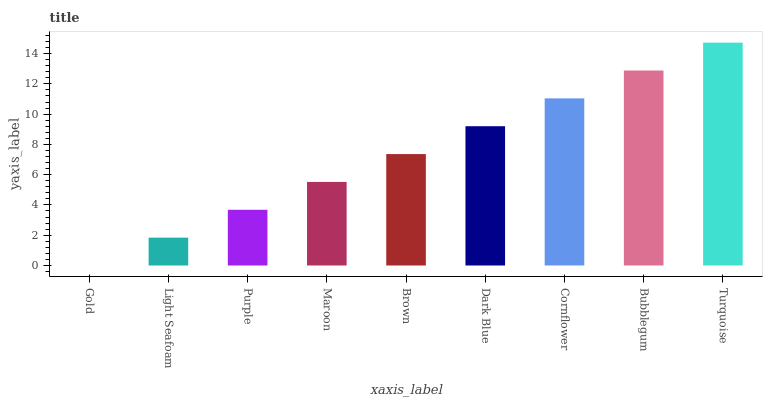Is Gold the minimum?
Answer yes or no. Yes. Is Turquoise the maximum?
Answer yes or no. Yes. Is Light Seafoam the minimum?
Answer yes or no. No. Is Light Seafoam the maximum?
Answer yes or no. No. Is Light Seafoam greater than Gold?
Answer yes or no. Yes. Is Gold less than Light Seafoam?
Answer yes or no. Yes. Is Gold greater than Light Seafoam?
Answer yes or no. No. Is Light Seafoam less than Gold?
Answer yes or no. No. Is Brown the high median?
Answer yes or no. Yes. Is Brown the low median?
Answer yes or no. Yes. Is Light Seafoam the high median?
Answer yes or no. No. Is Purple the low median?
Answer yes or no. No. 